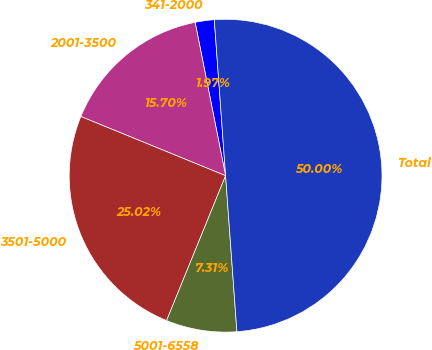<chart> <loc_0><loc_0><loc_500><loc_500><pie_chart><fcel>341-2000<fcel>2001-3500<fcel>3501-5000<fcel>5001-6558<fcel>Total<nl><fcel>1.97%<fcel>15.7%<fcel>25.02%<fcel>7.31%<fcel>50.0%<nl></chart> 